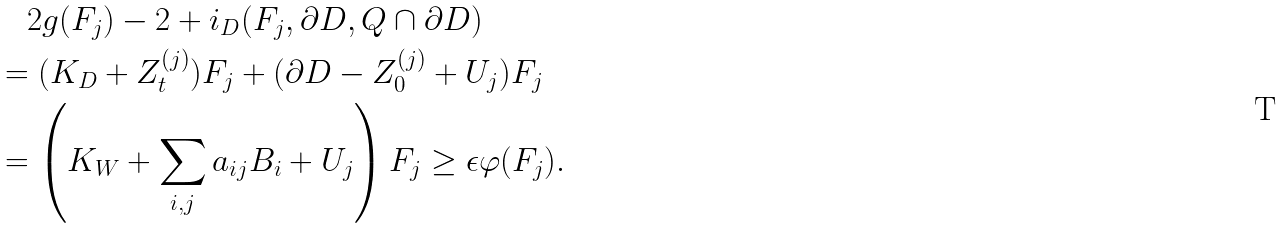Convert formula to latex. <formula><loc_0><loc_0><loc_500><loc_500>& \quad 2 g ( F _ { j } ) - 2 + i _ { D } ( F _ { j } , \partial D , Q \cap \partial D ) \\ & = ( K _ { D } + Z _ { t } ^ { ( j ) } ) F _ { j } + ( \partial D - Z _ { 0 } ^ { ( j ) } + U _ { j } ) F _ { j } \\ & = \left ( K _ { W } + \sum _ { i , j } a _ { i j } B _ { i } + U _ { j } \right ) F _ { j } \geq \epsilon \varphi ( F _ { j } ) .</formula> 